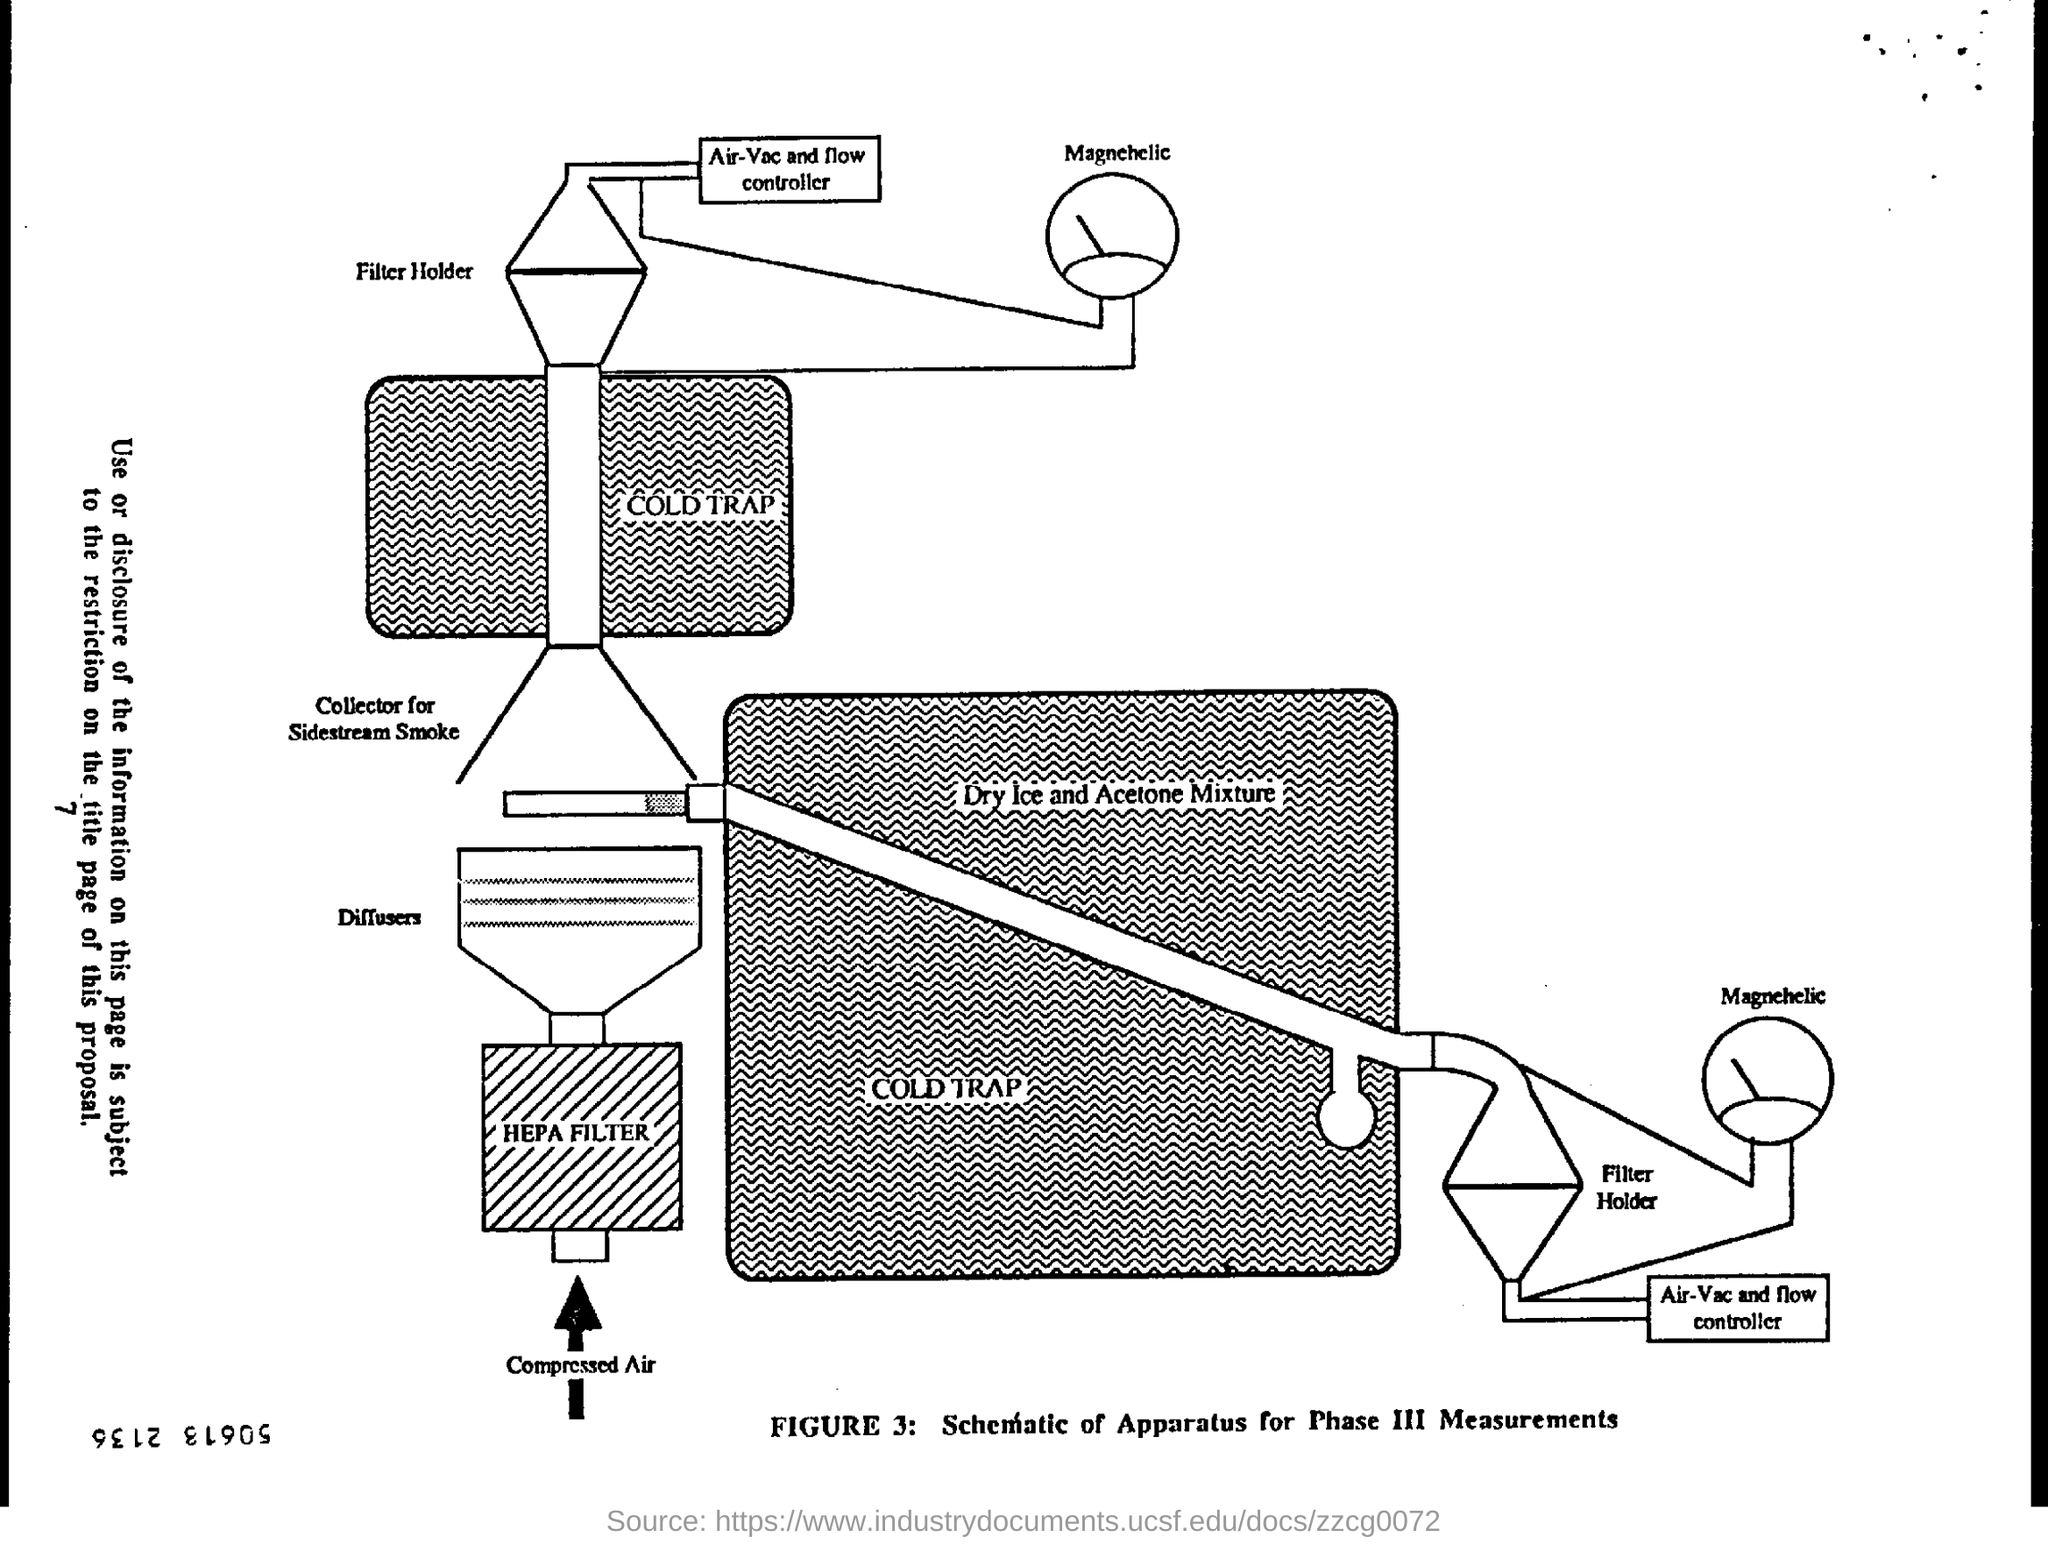What is the title of figure 3?
Keep it short and to the point. Schematic of Apparatus for Phase III Measurements. What mixture does the cold trap contain?
Make the answer very short. Dry ice and acetone mixture. 